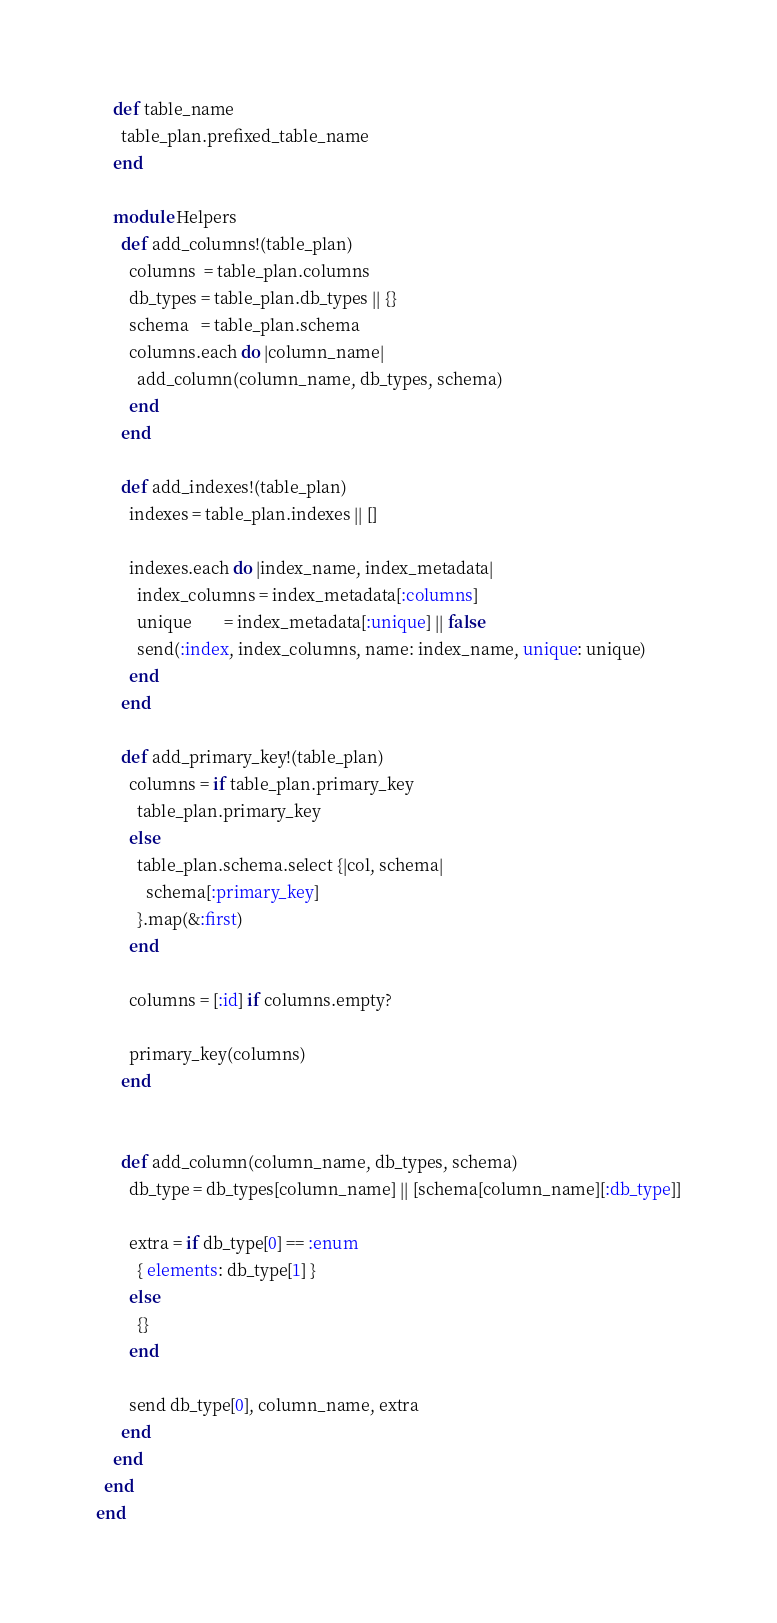<code> <loc_0><loc_0><loc_500><loc_500><_Ruby_>
    def table_name
      table_plan.prefixed_table_name
    end

    module Helpers
      def add_columns!(table_plan)
        columns  = table_plan.columns
        db_types = table_plan.db_types || {}
        schema   = table_plan.schema
        columns.each do |column_name|
          add_column(column_name, db_types, schema)
        end
      end

      def add_indexes!(table_plan)
        indexes = table_plan.indexes || []

        indexes.each do |index_name, index_metadata|
          index_columns = index_metadata[:columns]
          unique        = index_metadata[:unique] || false
          send(:index, index_columns, name: index_name, unique: unique)
        end
      end

      def add_primary_key!(table_plan)
        columns = if table_plan.primary_key
          table_plan.primary_key
        else
          table_plan.schema.select {|col, schema|
            schema[:primary_key]
          }.map(&:first)
        end

        columns = [:id] if columns.empty?

        primary_key(columns)
      end


      def add_column(column_name, db_types, schema)
        db_type = db_types[column_name] || [schema[column_name][:db_type]]

        extra = if db_type[0] == :enum
          { elements: db_type[1] }
        else
          {}
        end

        send db_type[0], column_name, extra
      end
    end
  end
end
</code> 